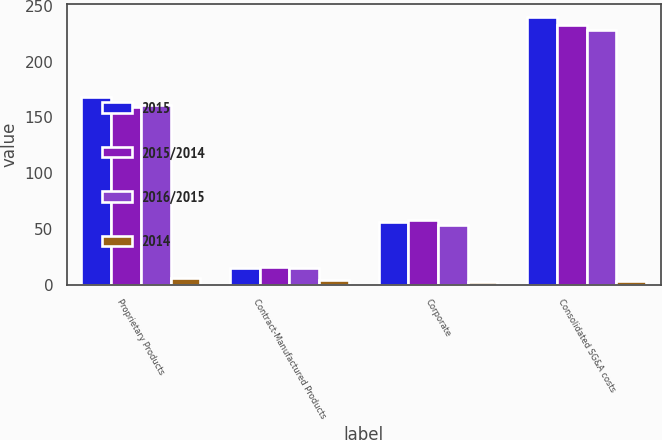Convert chart to OTSL. <chart><loc_0><loc_0><loc_500><loc_500><stacked_bar_chart><ecel><fcel>Proprietary Products<fcel>Contract-Manufactured Products<fcel>Corporate<fcel>Consolidated SG&A costs<nl><fcel>2015<fcel>168.3<fcel>15.2<fcel>56.3<fcel>239.8<nl><fcel>2015/2014<fcel>159.4<fcel>15.8<fcel>57.8<fcel>233<nl><fcel>2016/2015<fcel>160.7<fcel>14.8<fcel>53.2<fcel>228.7<nl><fcel>2014<fcel>5.6<fcel>3.8<fcel>2.6<fcel>2.9<nl></chart> 